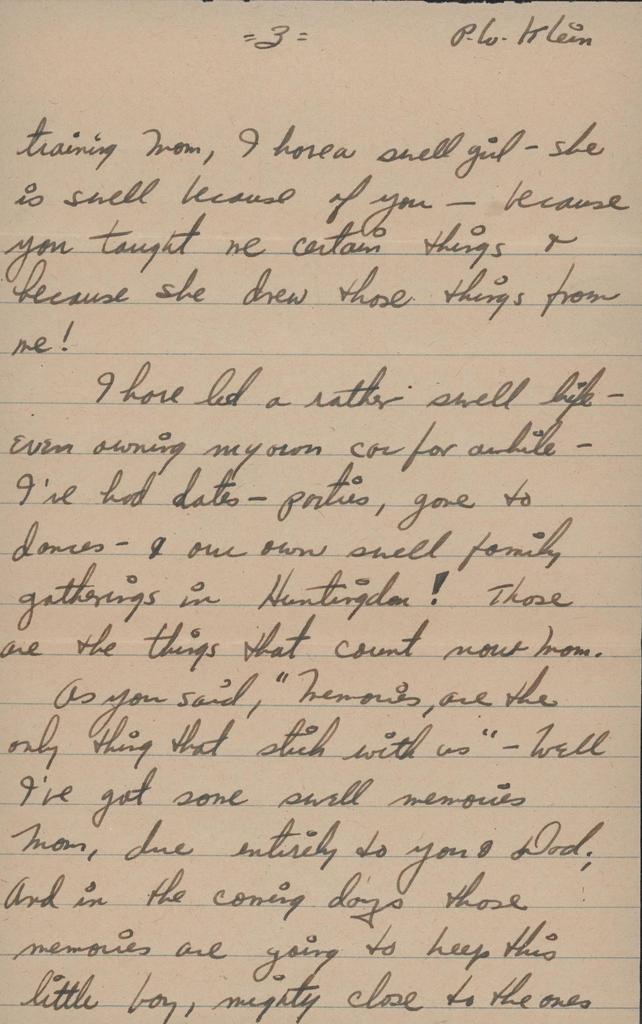Provide a one-sentence caption for the provided image. A letter written in cursive by P.W Klein. 